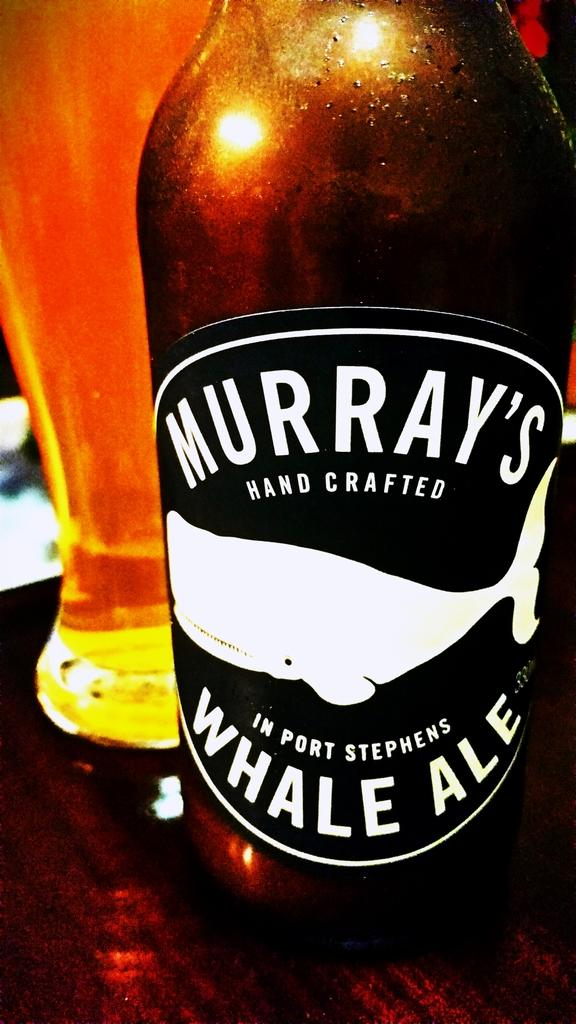<image>
Summarize the visual content of the image. A bottle of Murray's Hand Crafted Whale Ale beer brewed in Port Stephens. 